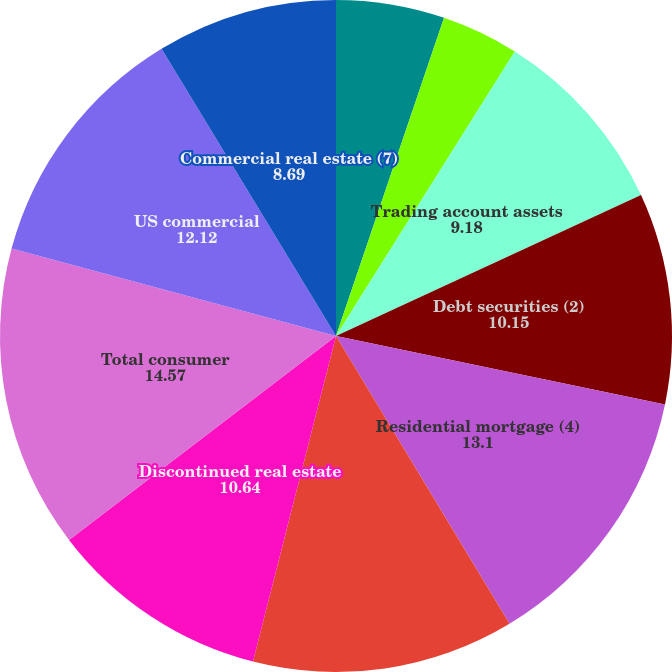Convert chart. <chart><loc_0><loc_0><loc_500><loc_500><pie_chart><fcel>Time deposits placed and other<fcel>Federal funds sold and<fcel>Trading account assets<fcel>Debt securities (2)<fcel>Residential mortgage (4)<fcel>Home equity<fcel>Discontinued real estate<fcel>Total consumer<fcel>US commercial<fcel>Commercial real estate (7)<nl><fcel>5.21%<fcel>3.72%<fcel>9.18%<fcel>10.15%<fcel>13.1%<fcel>12.61%<fcel>10.64%<fcel>14.57%<fcel>12.12%<fcel>8.69%<nl></chart> 